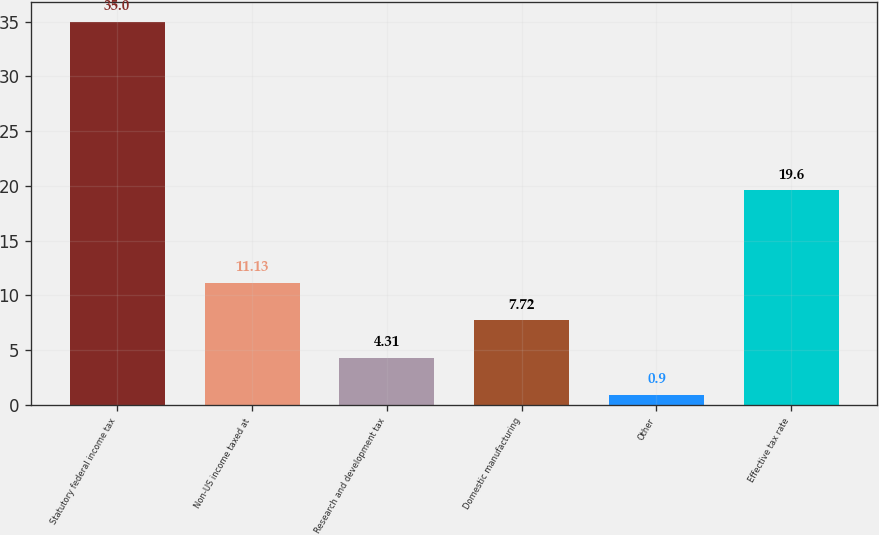<chart> <loc_0><loc_0><loc_500><loc_500><bar_chart><fcel>Statutory federal income tax<fcel>Non-US income taxed at<fcel>Research and development tax<fcel>Domestic manufacturing<fcel>Other<fcel>Effective tax rate<nl><fcel>35<fcel>11.13<fcel>4.31<fcel>7.72<fcel>0.9<fcel>19.6<nl></chart> 